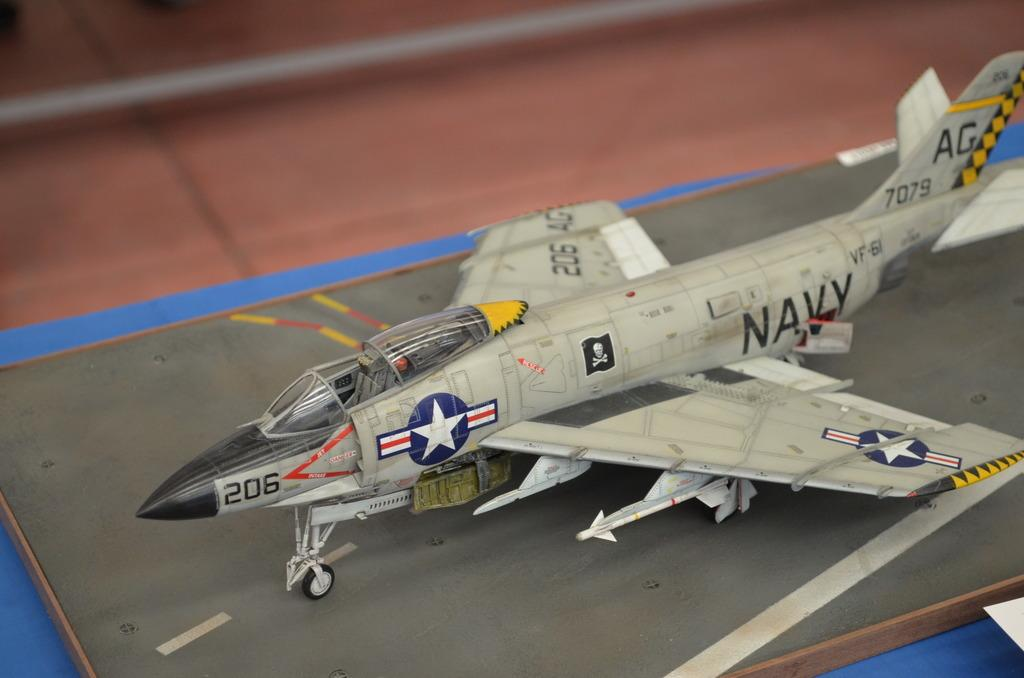<image>
Describe the image concisely. An model airplane of a navy jet sits on a table. 